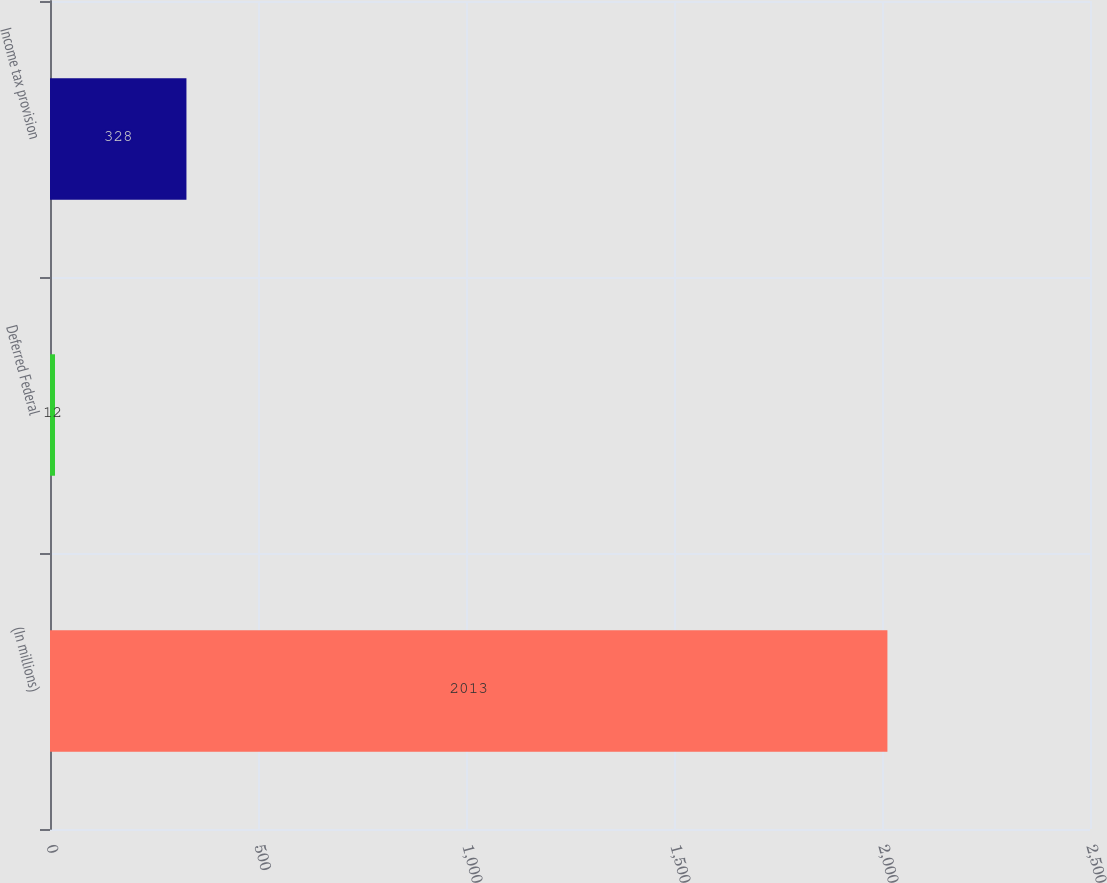Convert chart. <chart><loc_0><loc_0><loc_500><loc_500><bar_chart><fcel>(In millions)<fcel>Deferred Federal<fcel>Income tax provision<nl><fcel>2013<fcel>12<fcel>328<nl></chart> 